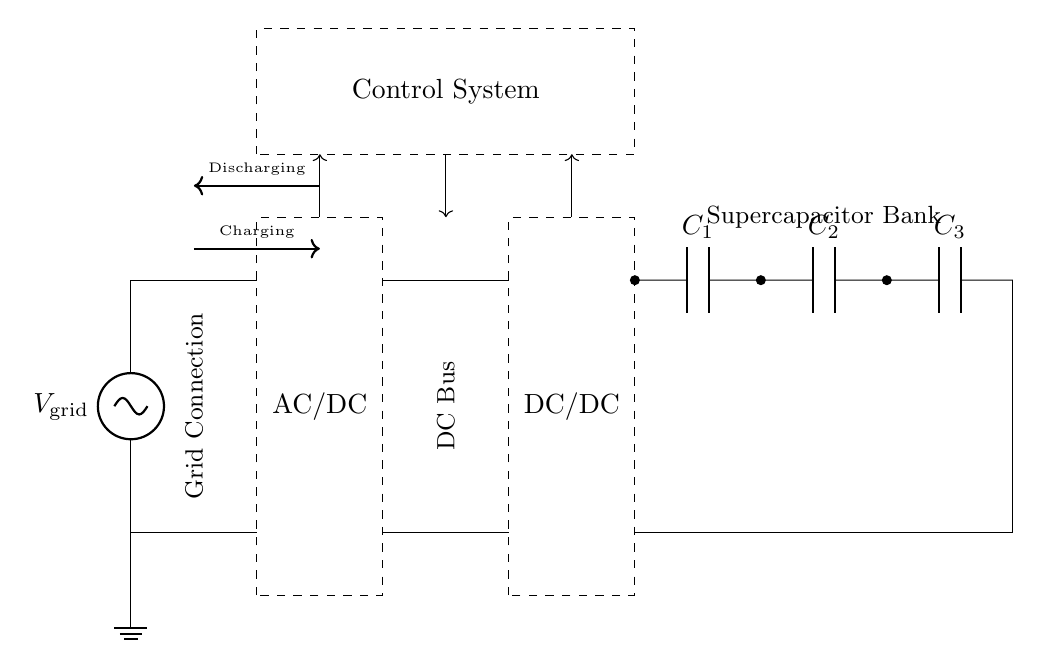What is the input voltage of the circuit? The circuit has an input voltage labeled as V grid, indicating the connection to the grid's voltage source, which is provided by the grid.
Answer: V grid What is the purpose of the AC/DC converter in this circuit? The AC/DC converter is responsible for converting the alternating current from the grid into direct current to be used by the subsequent components in the circuit.
Answer: Conversion of AC to DC How many supercapacitors are connected in this circuit? There are three supercapacitors labeled as C1, C2, and C3 in the supercapacitor bank, as shown in the circuit diagram.
Answer: Three What is the function of the control system in this circuit? The control system manages the power flow between components, ensuring proper charging and discharging of the supercapacitors as labeled in the circuit.
Answer: Manage power flow In which direction does the charging current flow? The charging current flows from the DC bus to the supercapacitor bank, as indicated by the arrow pointing toward the capacitors in the charging arrow.
Answer: Toward supercapacitor bank What type of converters are used in this circuit? The circuit uses an AC/DC converter to convert AC to DC and a DC/DC converter to manage the voltage levels between the DC bus and the supercapacitors.
Answer: AC/DC and DC/DC 